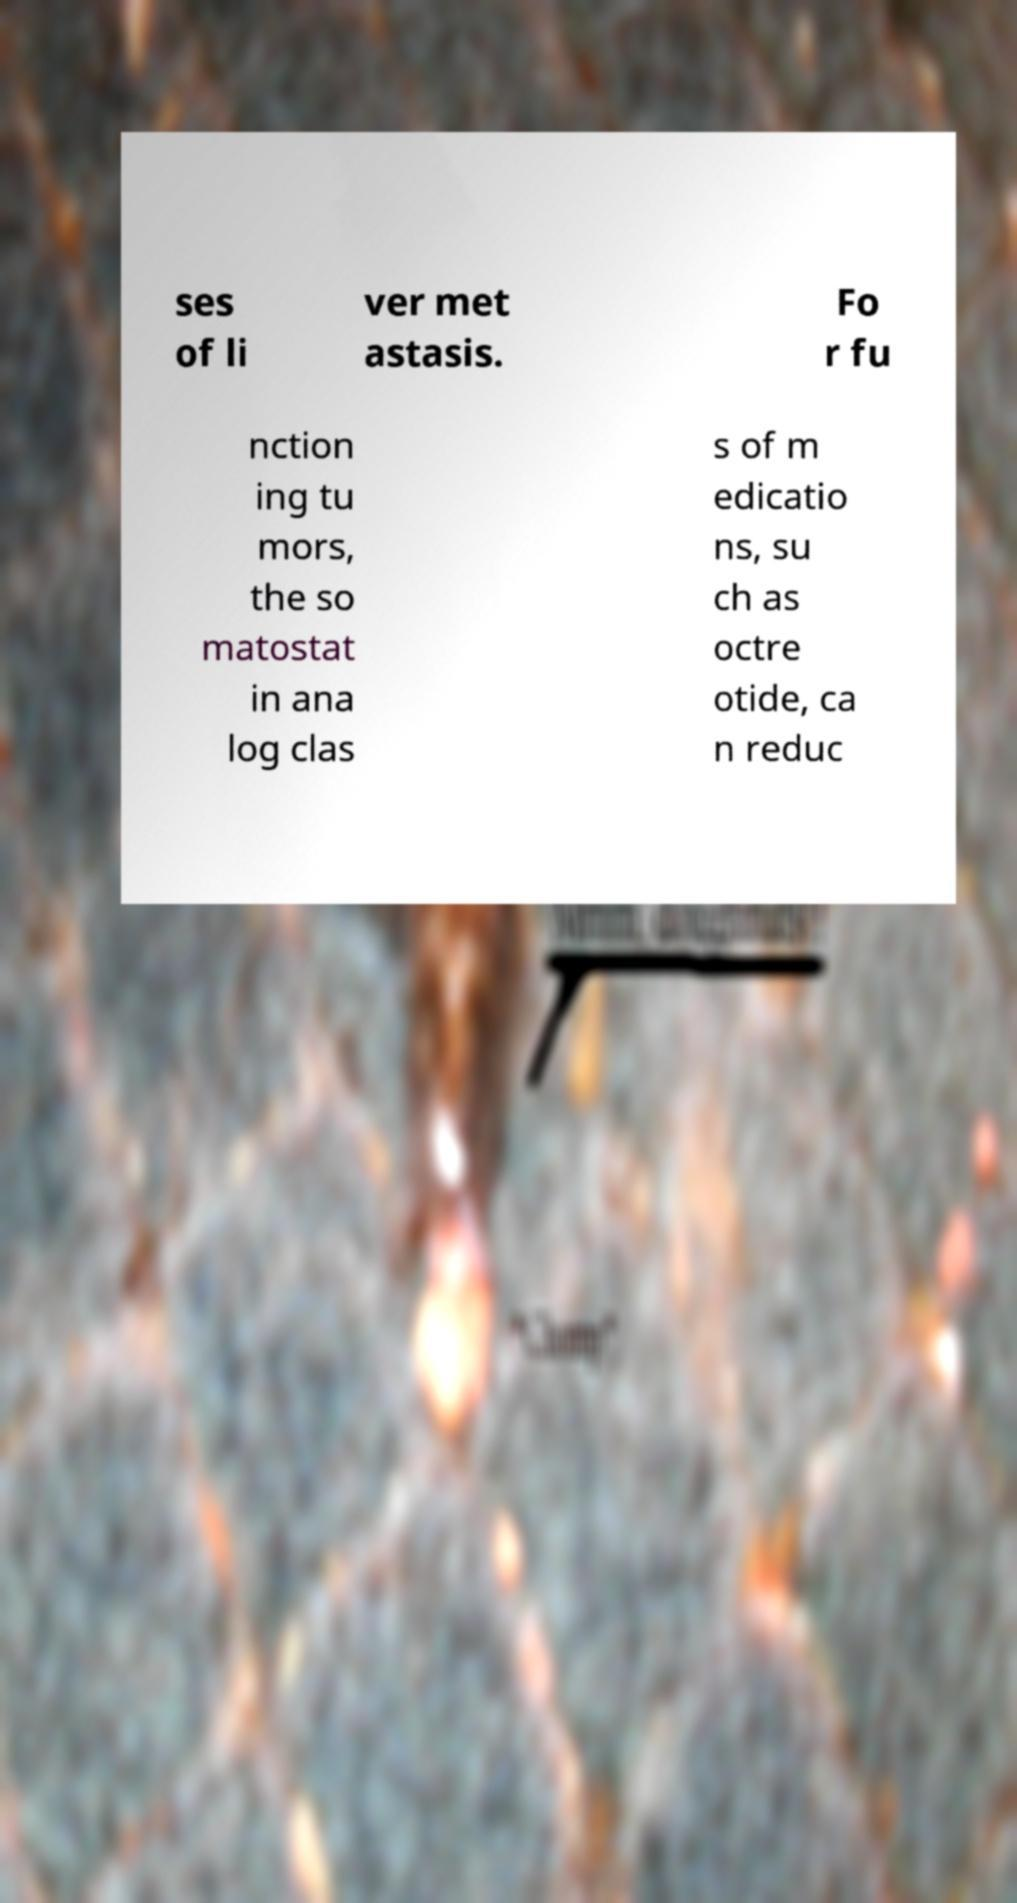Please read and relay the text visible in this image. What does it say? ses of li ver met astasis. Fo r fu nction ing tu mors, the so matostat in ana log clas s of m edicatio ns, su ch as octre otide, ca n reduc 